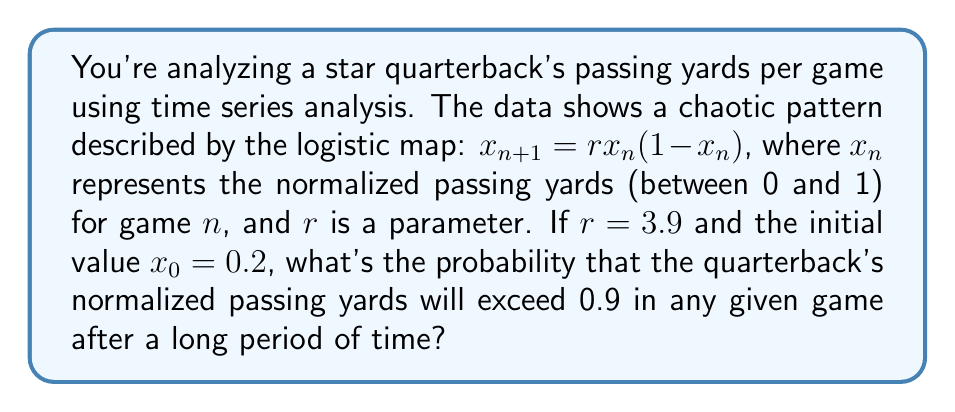Solve this math problem. Let's approach this step-by-step:

1) The logistic map $x_{n+1} = rx_n(1-x_n)$ with $r = 3.9$ exhibits chaotic behavior.

2) In chaos theory, for such systems, we can use the concept of invariant density to find the long-term probability distribution of the system.

3) For the logistic map, the invariant density $\rho(x)$ is given by:

   $$\rho(x) = \frac{1}{\pi\sqrt{x(1-x)}}$$

4) To find the probability that $x > 0.9$, we need to integrate this density from 0.9 to 1:

   $$P(x > 0.9) = \int_{0.9}^1 \frac{1}{\pi\sqrt{x(1-x)}} dx$$

5) This integral can be solved using the substitution $x = \sin^2(\theta)$:

   $$P(x > 0.9) = \frac{2}{\pi} \int_{\arcsin(\sqrt{0.9})}^{\pi/2} d\theta = \frac{2}{\pi} (\frac{\pi}{2} - \arcsin(\sqrt{0.9}))$$

6) Calculating this:

   $$P(x > 0.9) = \frac{2}{\pi} (\frac{\pi}{2} - \arcsin(\sqrt{0.9})) \approx 0.2048$$

Therefore, after a long period of time, the probability that the quarterback's normalized passing yards will exceed 0.9 in any given game is approximately 0.2048 or 20.48%.
Answer: 0.2048 